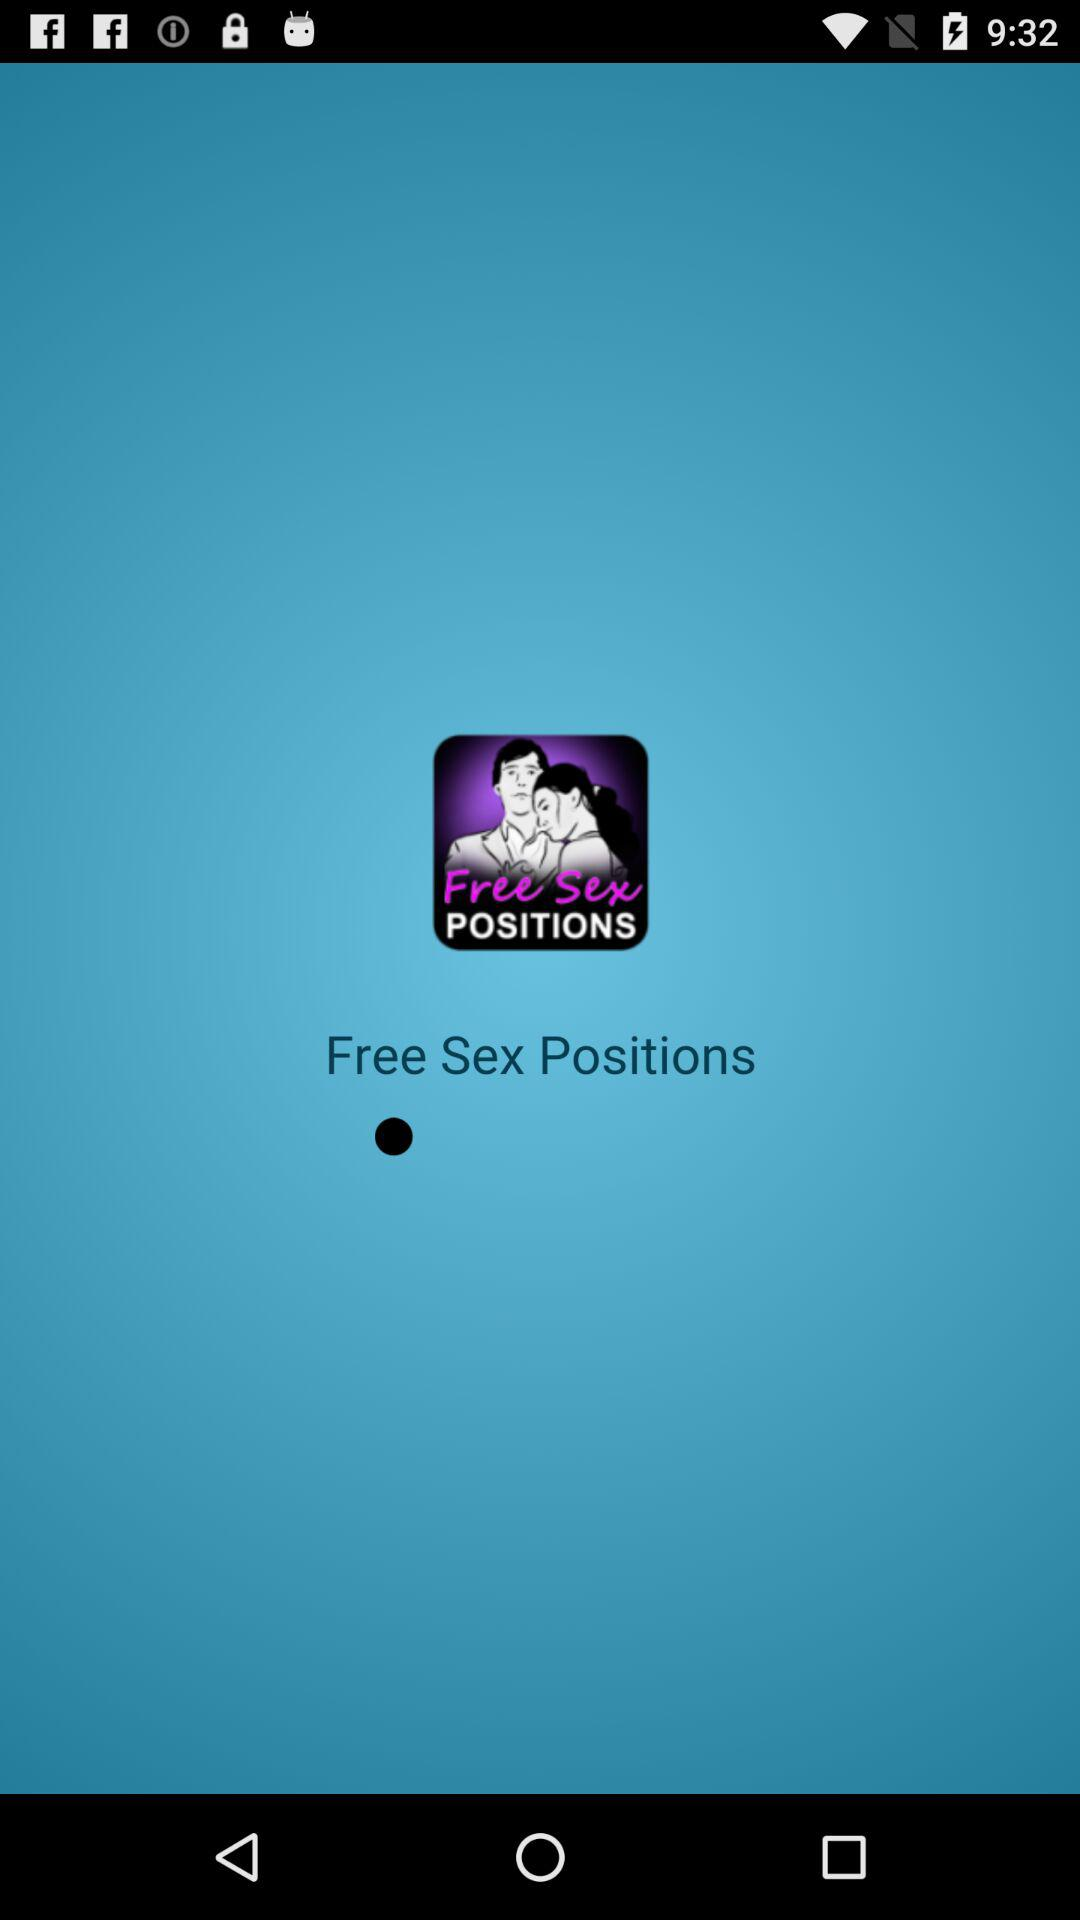What is the name of the application? The name of the application is "Free Sex Positions". 